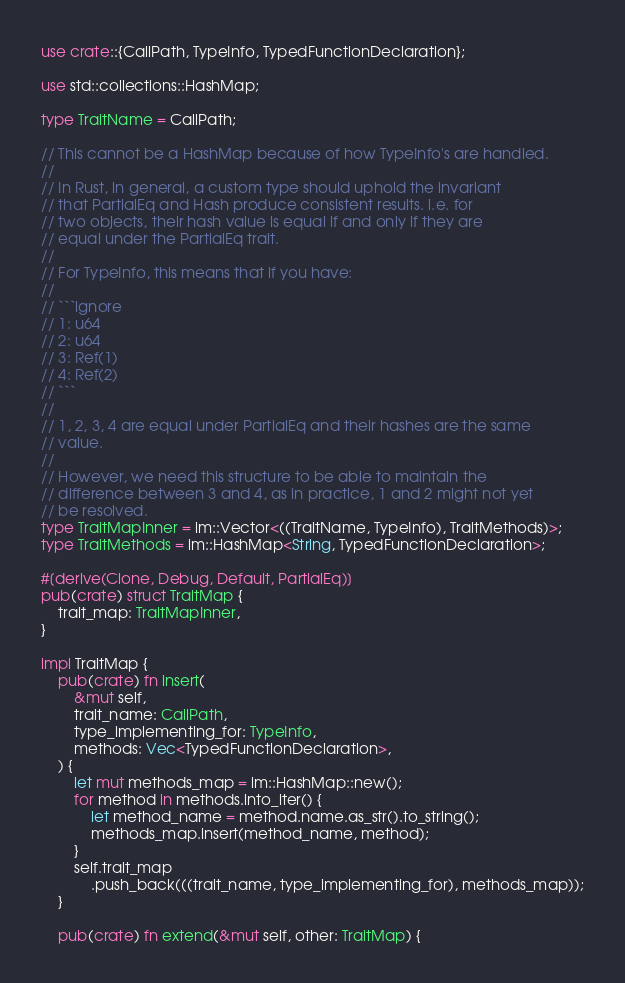<code> <loc_0><loc_0><loc_500><loc_500><_Rust_>use crate::{CallPath, TypeInfo, TypedFunctionDeclaration};

use std::collections::HashMap;

type TraitName = CallPath;

// This cannot be a HashMap because of how TypeInfo's are handled.
//
// In Rust, in general, a custom type should uphold the invariant
// that PartialEq and Hash produce consistent results. i.e. for
// two objects, their hash value is equal if and only if they are
// equal under the PartialEq trait.
//
// For TypeInfo, this means that if you have:
//
// ```ignore
// 1: u64
// 2: u64
// 3: Ref(1)
// 4: Ref(2)
// ```
//
// 1, 2, 3, 4 are equal under PartialEq and their hashes are the same
// value.
//
// However, we need this structure to be able to maintain the
// difference between 3 and 4, as in practice, 1 and 2 might not yet
// be resolved.
type TraitMapInner = im::Vector<((TraitName, TypeInfo), TraitMethods)>;
type TraitMethods = im::HashMap<String, TypedFunctionDeclaration>;

#[derive(Clone, Debug, Default, PartialEq)]
pub(crate) struct TraitMap {
    trait_map: TraitMapInner,
}

impl TraitMap {
    pub(crate) fn insert(
        &mut self,
        trait_name: CallPath,
        type_implementing_for: TypeInfo,
        methods: Vec<TypedFunctionDeclaration>,
    ) {
        let mut methods_map = im::HashMap::new();
        for method in methods.into_iter() {
            let method_name = method.name.as_str().to_string();
            methods_map.insert(method_name, method);
        }
        self.trait_map
            .push_back(((trait_name, type_implementing_for), methods_map));
    }

    pub(crate) fn extend(&mut self, other: TraitMap) {</code> 